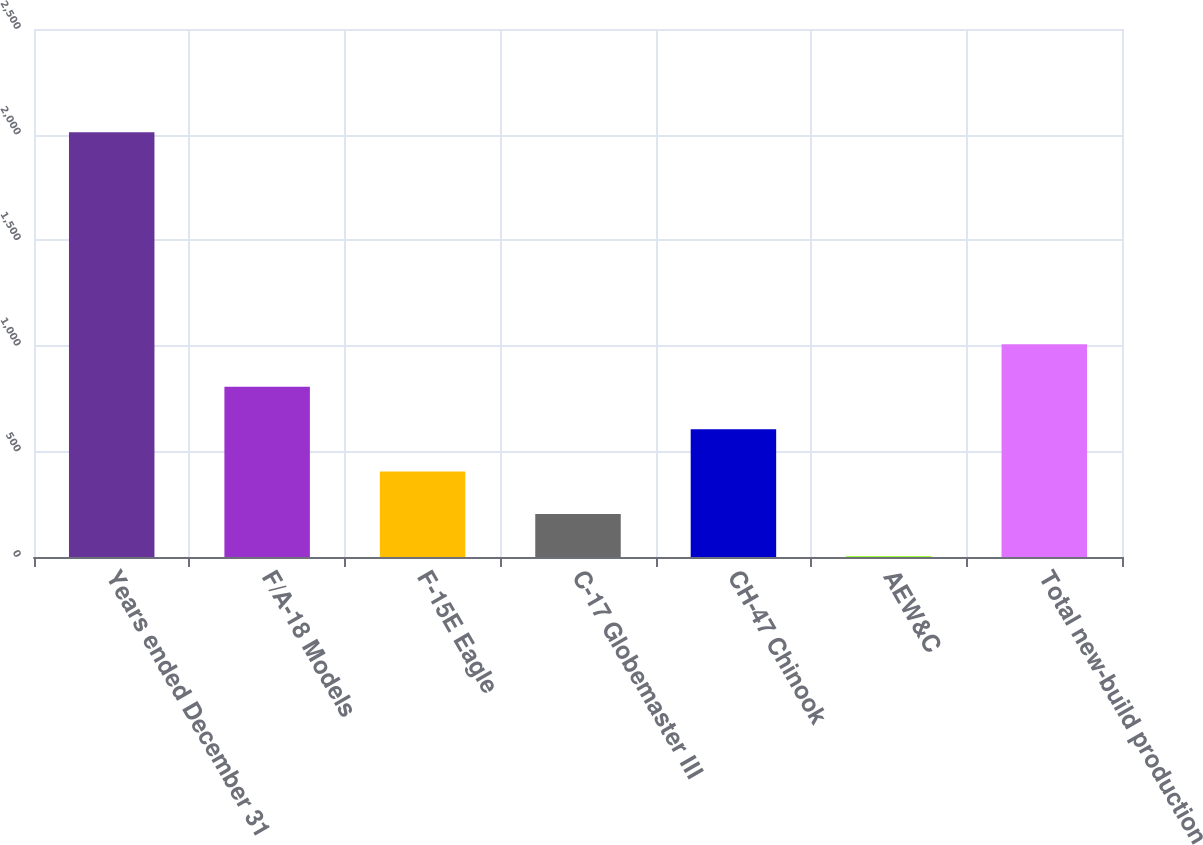<chart> <loc_0><loc_0><loc_500><loc_500><bar_chart><fcel>Years ended December 31<fcel>F/A-18 Models<fcel>F-15E Eagle<fcel>C-17 Globemaster III<fcel>CH-47 Chinook<fcel>AEW&C<fcel>Total new-build production<nl><fcel>2011<fcel>806.2<fcel>404.6<fcel>203.8<fcel>605.4<fcel>3<fcel>1007<nl></chart> 